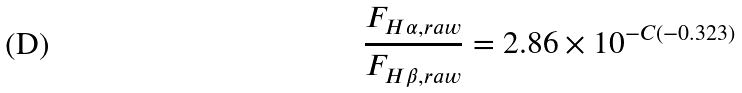<formula> <loc_0><loc_0><loc_500><loc_500>\frac { F _ { H \alpha , r a w } } { F _ { H \beta , r a w } } = 2 . 8 6 \times 1 0 ^ { - C ( - 0 . 3 2 3 ) }</formula> 